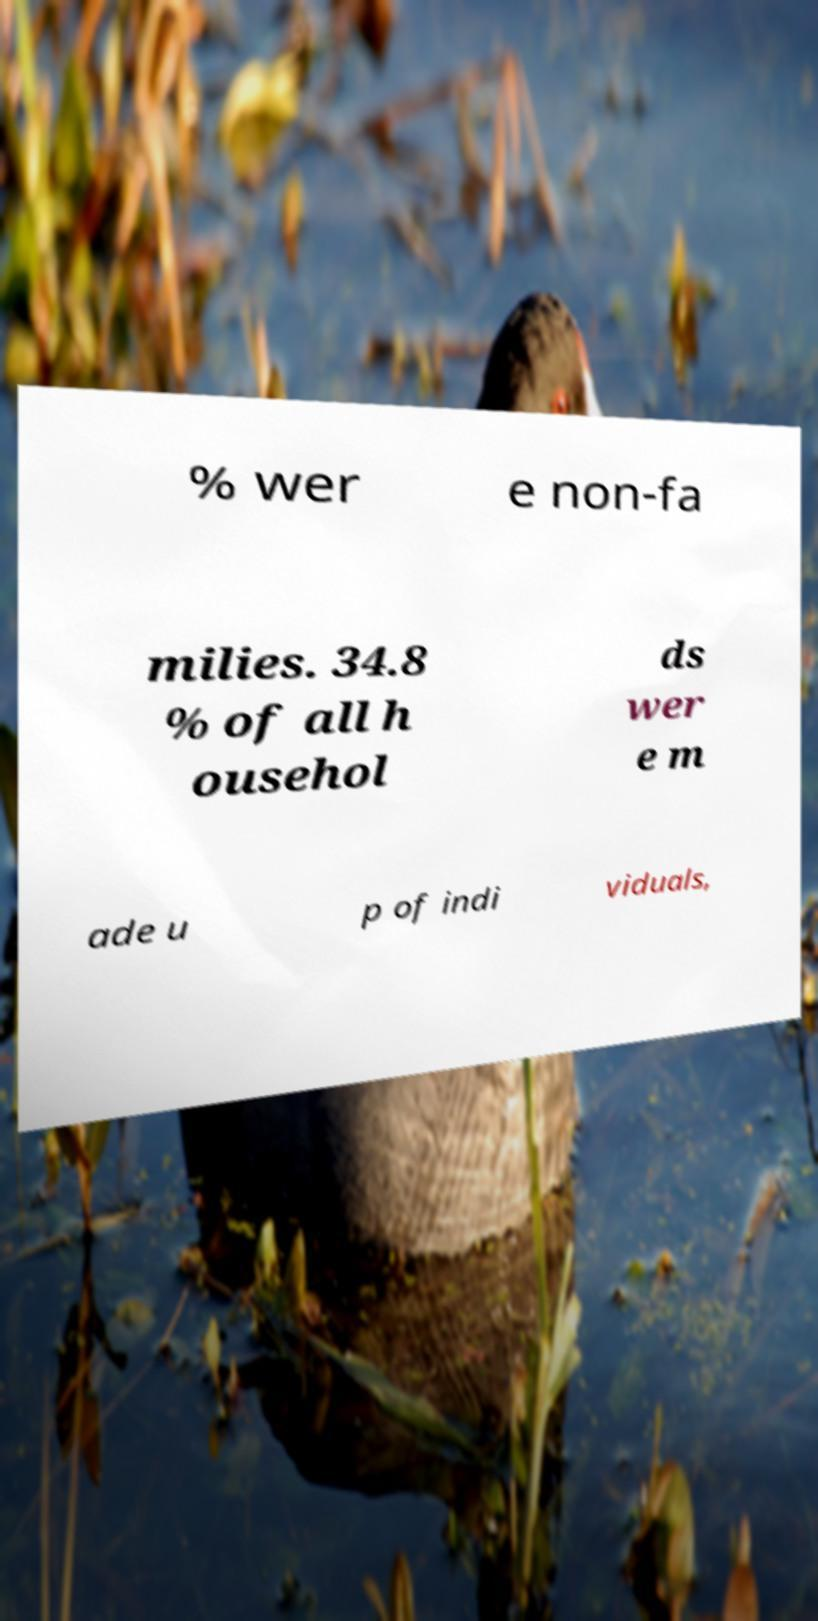I need the written content from this picture converted into text. Can you do that? % wer e non-fa milies. 34.8 % of all h ousehol ds wer e m ade u p of indi viduals, 